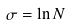<formula> <loc_0><loc_0><loc_500><loc_500>\sigma = \ln N</formula> 